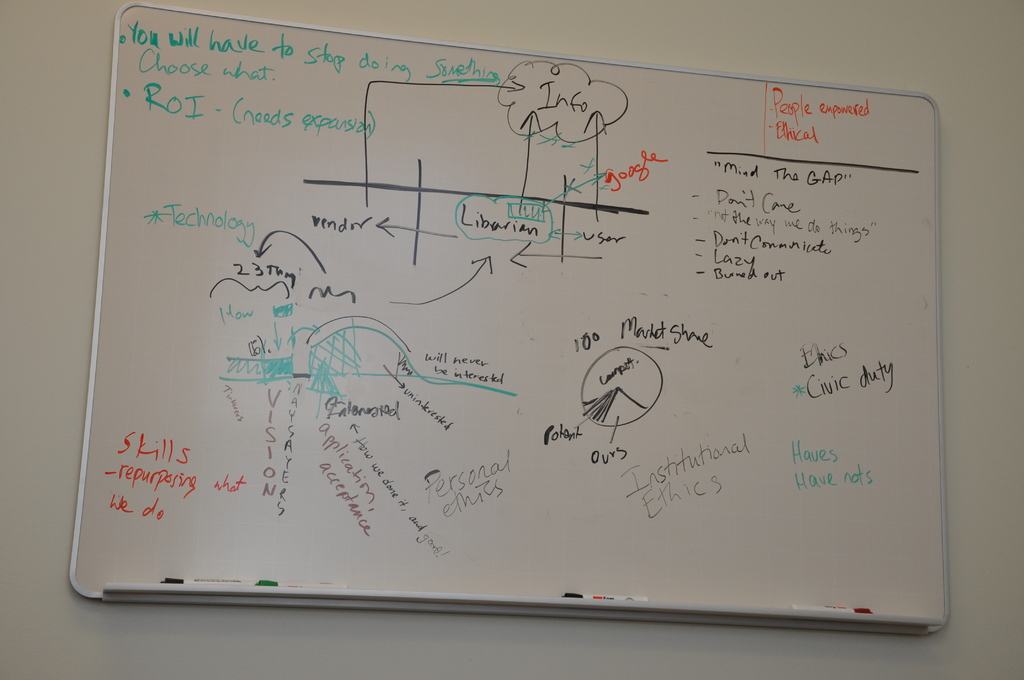What do you see happening in this image?
 The image captures a brainstorming session on a whiteboard, filled with a variety of text and drawings in different colors. The central theme revolves around technology, vendors, and institutional ethics. A phrase that stands out is "Choose what to stop doing", suggesting a focus on prioritization or efficiency. 

A scenario is being discussed, involving people connected to bridge a gap, possibly indicating a need for improved communication or collaboration. The term "ROI" is mentioned, hinting at a business context where return on investment is a key consideration. 

The text also raises questions such as "How many vendors?" and "100% Product Show", indicating a discussion about vendor management and product demonstration. 

Institutional ethics and personal ethics are also being considered, with a focus on reporting practices and adherence to standards. This suggests an emphasis on ethical conduct within the organization. 

Lastly, a figure labeled "Librarian" and a "User" are drawn, possibly representing different roles in the scenario. A bridge is also sketched, perhaps symbolizing the need to bridge a gap or overcome a challenge. 

Overall, the image provides a snapshot of a dynamic brainstorming session, with a focus on technology, vendor management, and ethics in an institutional setting. 